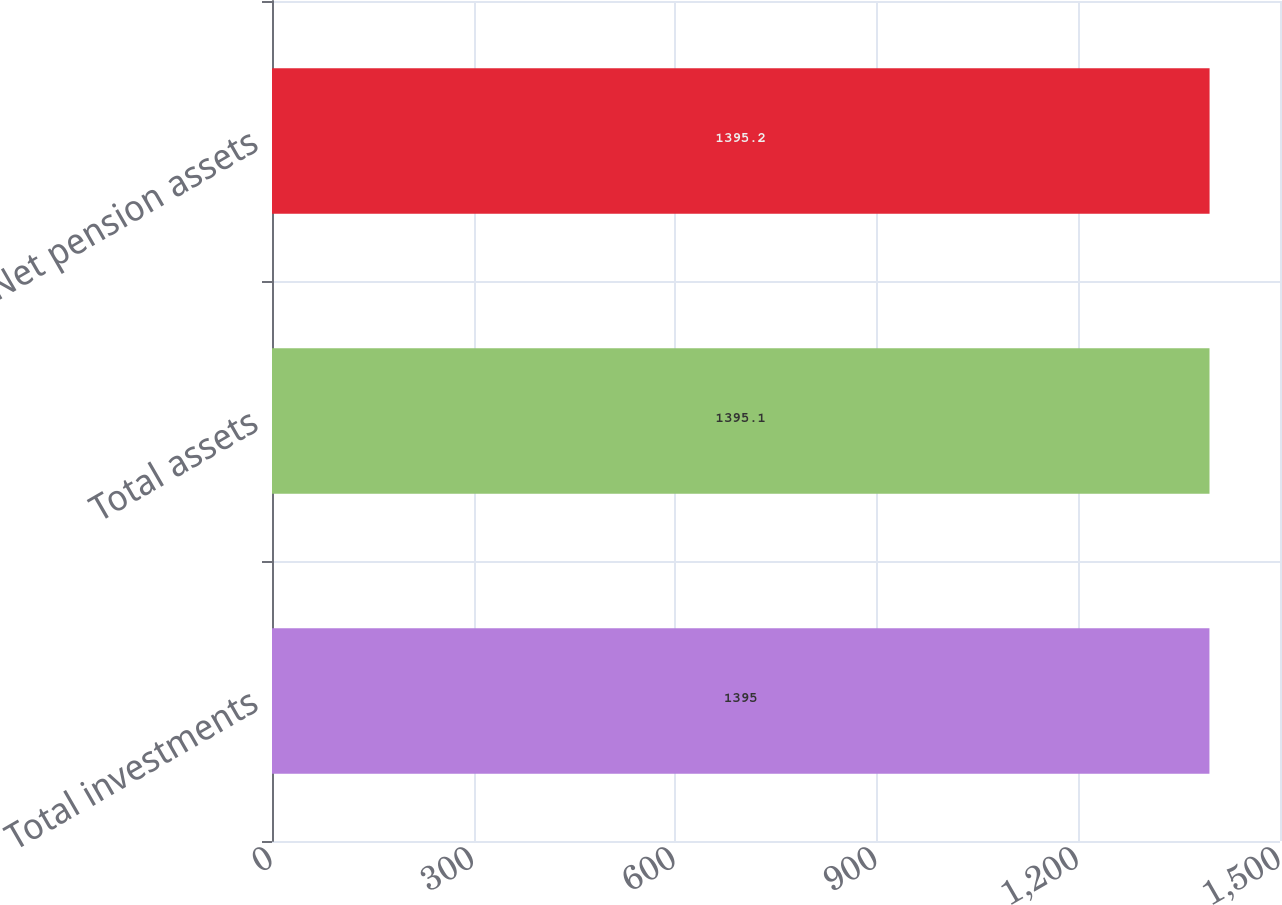Convert chart to OTSL. <chart><loc_0><loc_0><loc_500><loc_500><bar_chart><fcel>Total investments<fcel>Total assets<fcel>Net pension assets<nl><fcel>1395<fcel>1395.1<fcel>1395.2<nl></chart> 